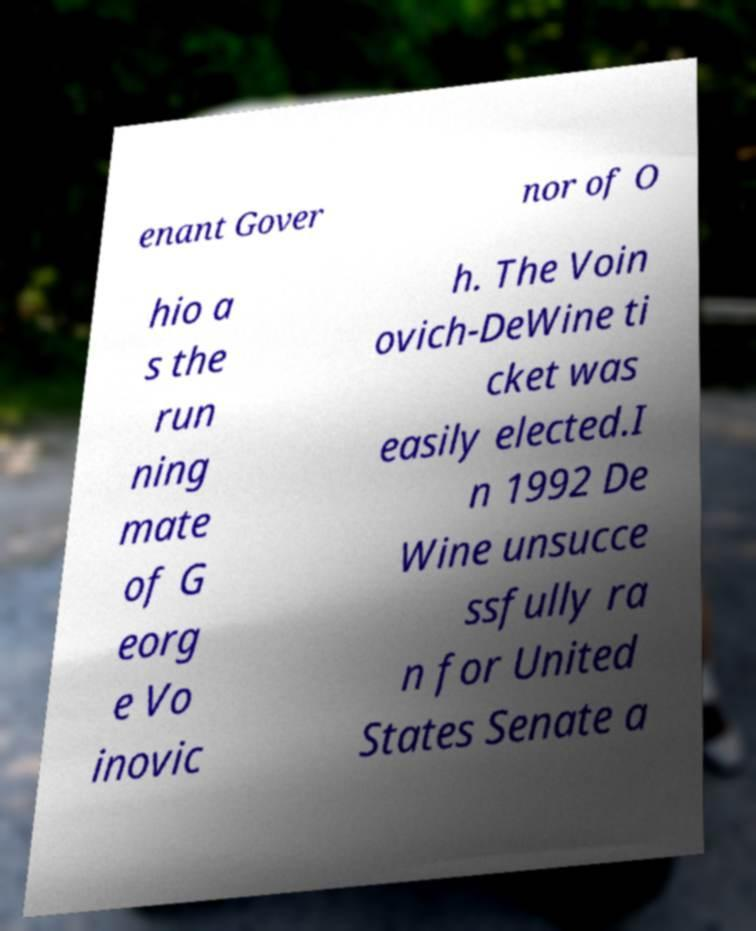Could you extract and type out the text from this image? enant Gover nor of O hio a s the run ning mate of G eorg e Vo inovic h. The Voin ovich-DeWine ti cket was easily elected.I n 1992 De Wine unsucce ssfully ra n for United States Senate a 